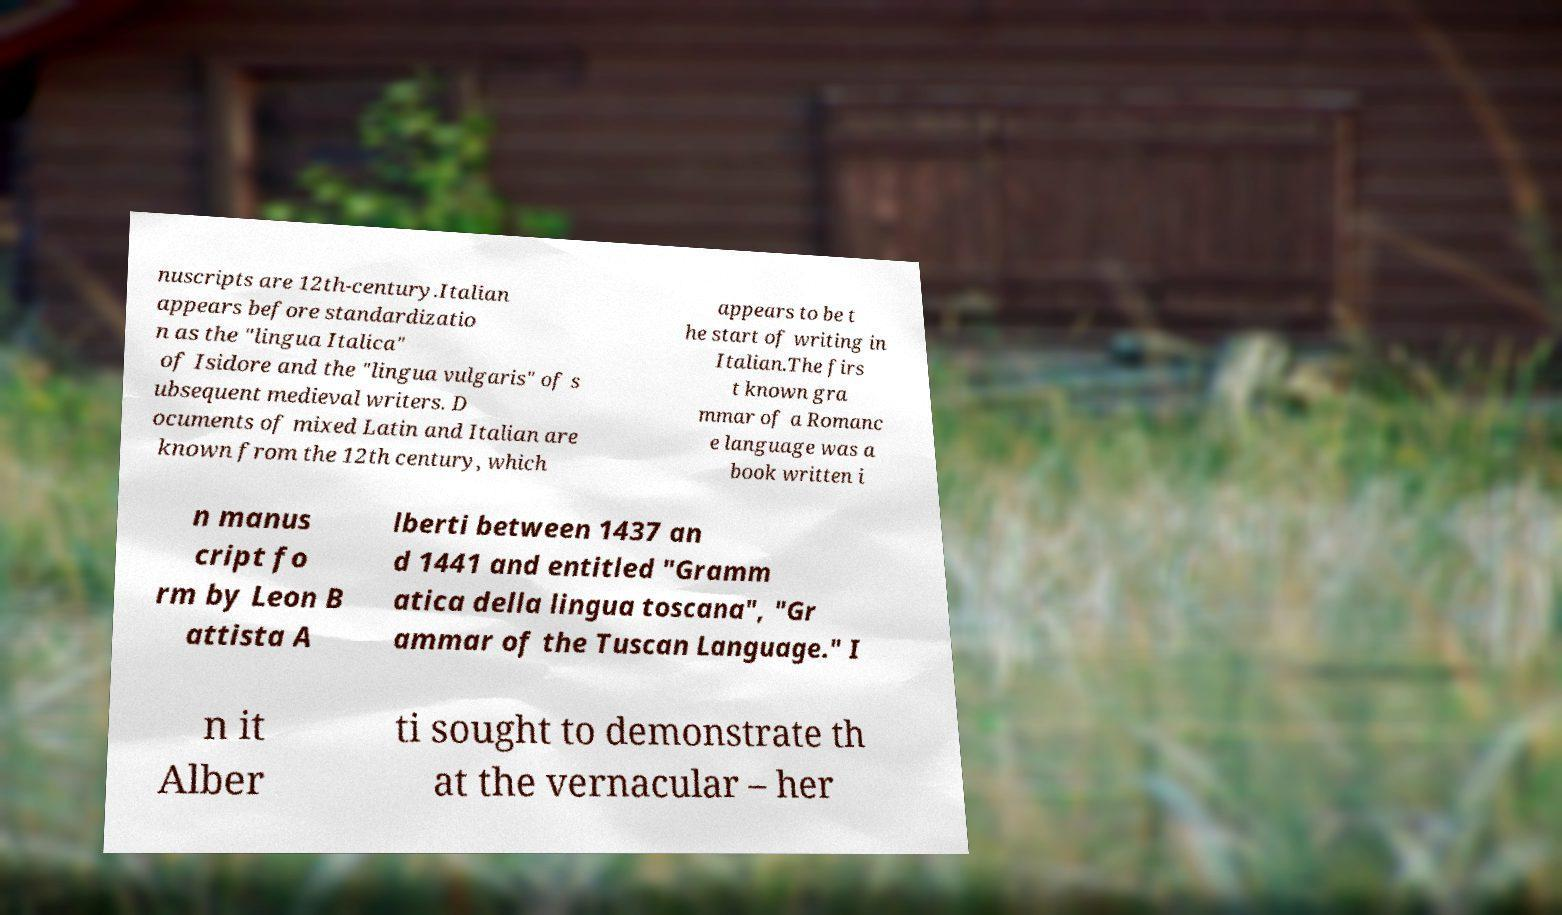Could you extract and type out the text from this image? nuscripts are 12th-century.Italian appears before standardizatio n as the "lingua Italica" of Isidore and the "lingua vulgaris" of s ubsequent medieval writers. D ocuments of mixed Latin and Italian are known from the 12th century, which appears to be t he start of writing in Italian.The firs t known gra mmar of a Romanc e language was a book written i n manus cript fo rm by Leon B attista A lberti between 1437 an d 1441 and entitled "Gramm atica della lingua toscana", "Gr ammar of the Tuscan Language." I n it Alber ti sought to demonstrate th at the vernacular – her 